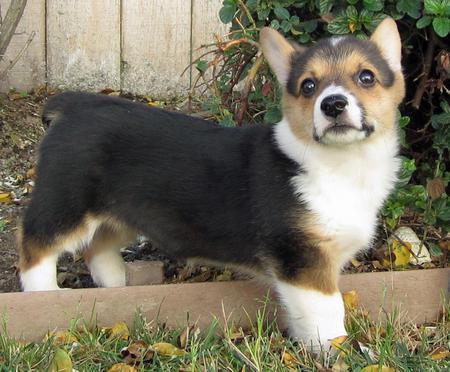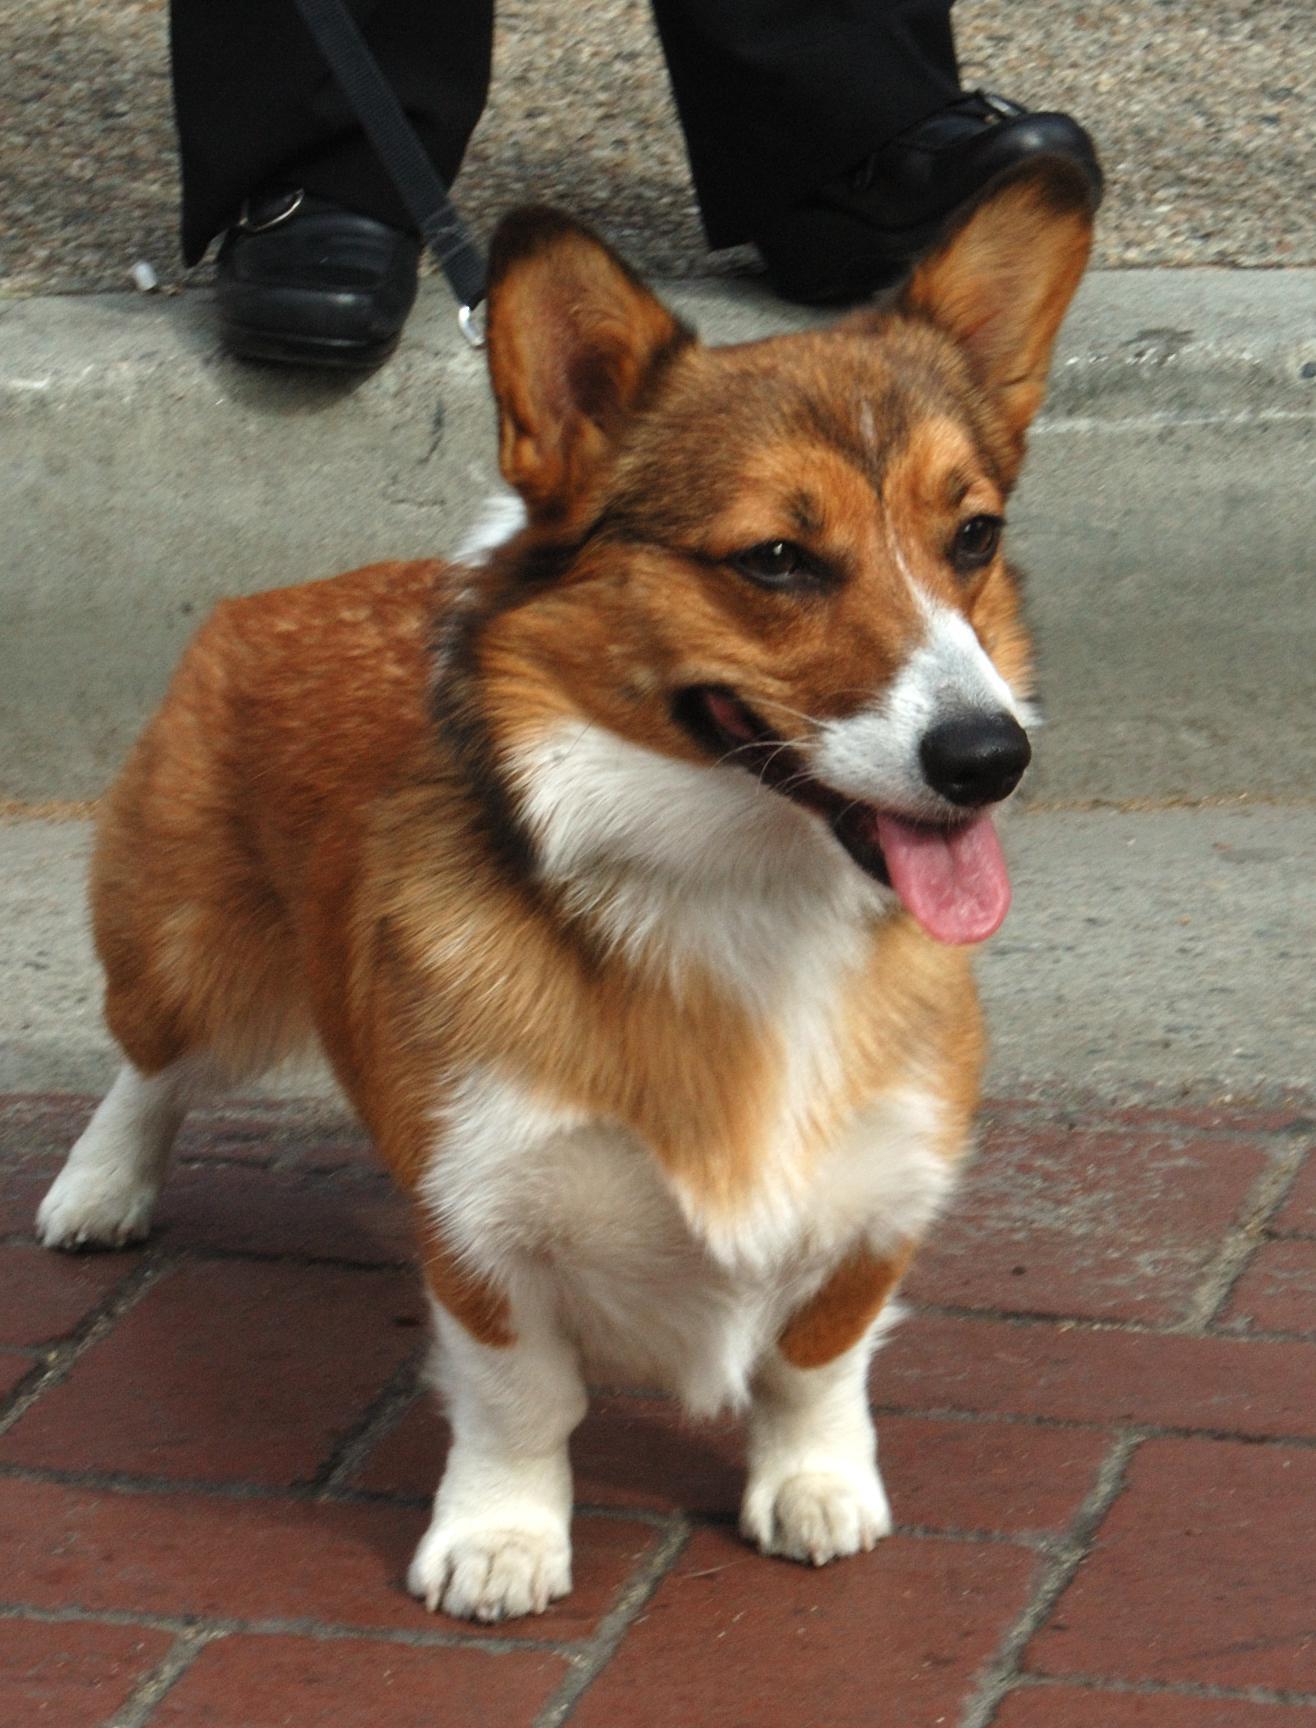The first image is the image on the left, the second image is the image on the right. For the images shown, is this caption "At least one dog is showing its tongue." true? Answer yes or no. Yes. 